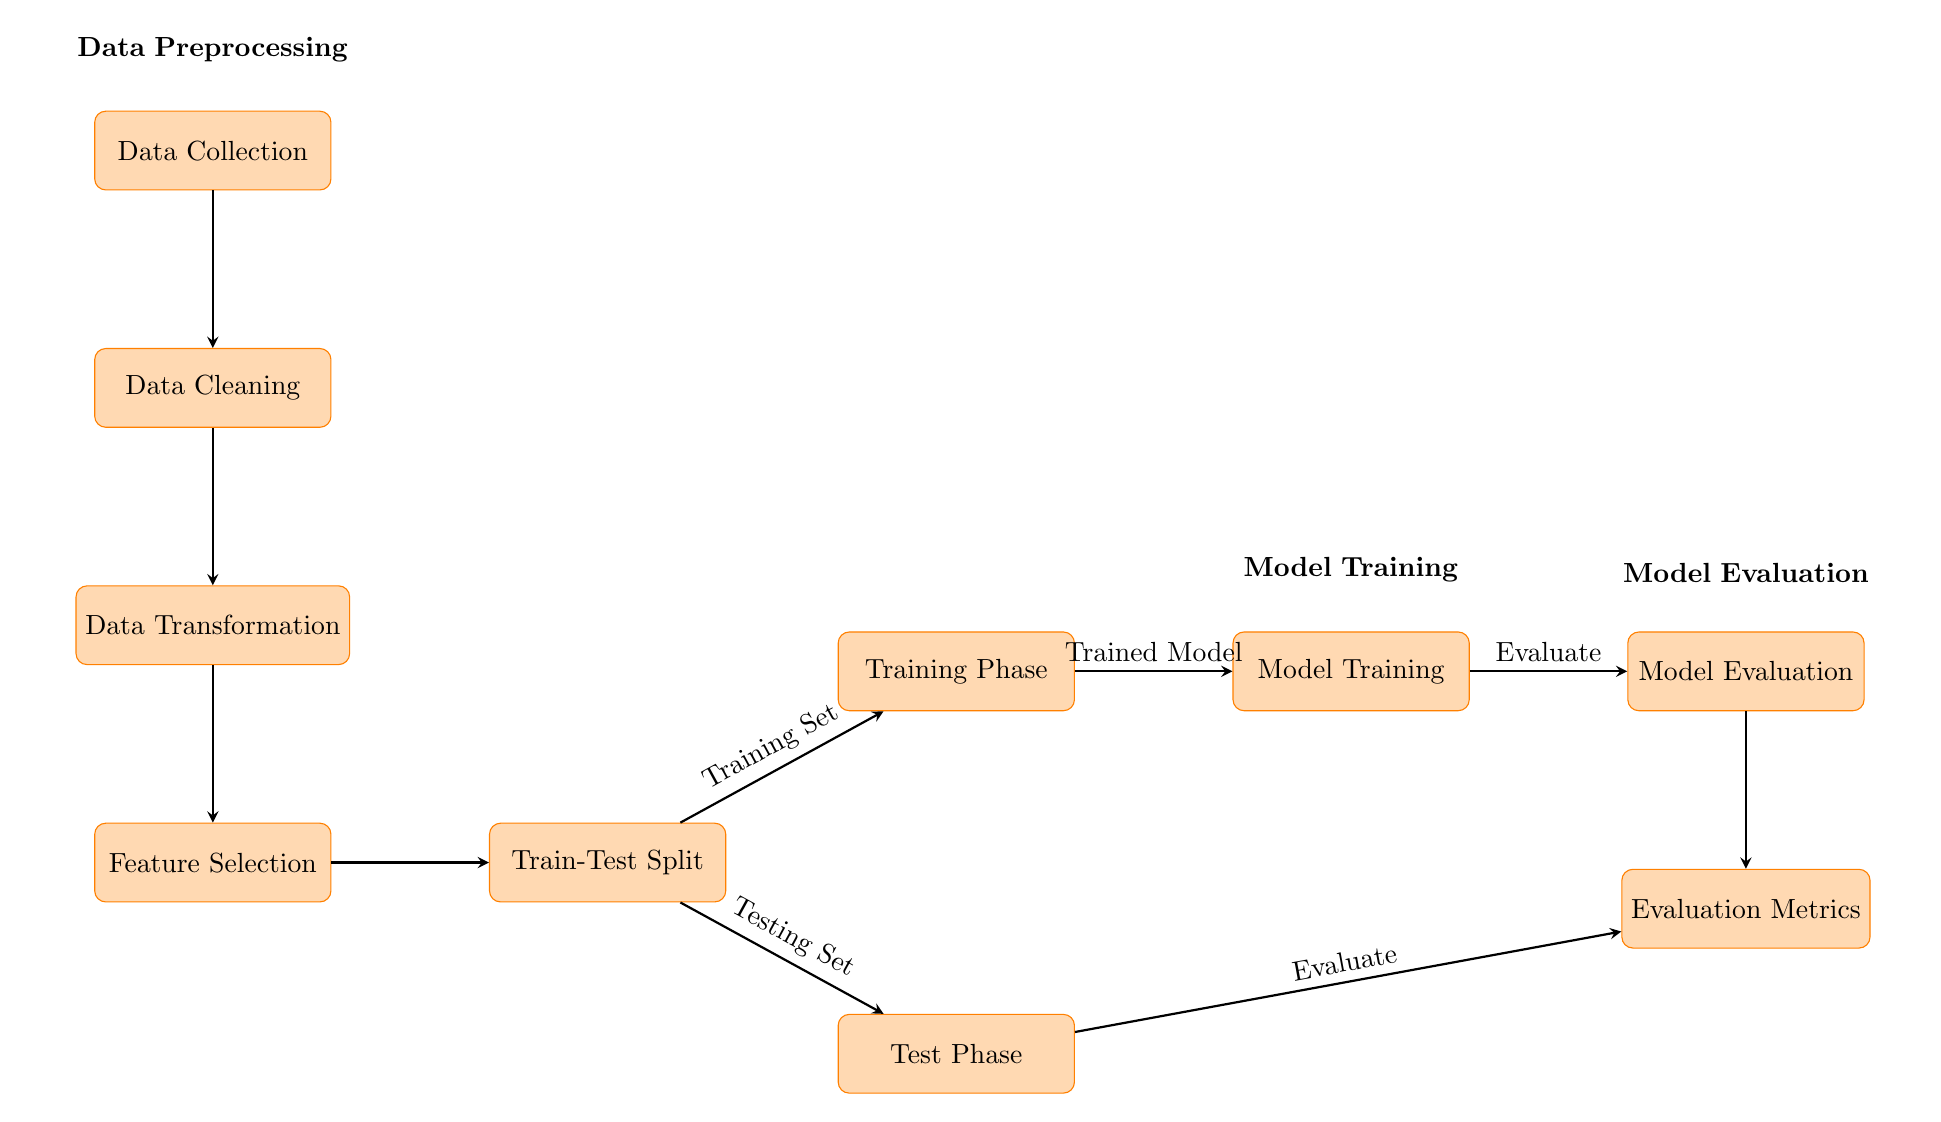What is the first step in the process? The first step in the diagram is "Data Collection," which is located at the top. This step initiates the flow that moves downward through the stages of preprocessing.
Answer: Data Collection How many processes are there in the Data Preprocessing phase? The diagram shows four processes in the Data Preprocessing phase: Data Collection, Data Cleaning, Data Transformation, and Feature Selection, listed vertically.
Answer: Four Which node receives input from the Feature Selection node? The "Train-Test Split" node receives input directly from the "Feature Selection" node, as indicated by the arrow connecting them to the right.
Answer: Train-Test Split What is the output of the Model Training phase? The output of the Model Training phase is labeled as "Trained Model," which flows to the "Model Evaluation" node.
Answer: Trained Model How are the Testing Set and Training Set related in this diagram? Both the Testing Set and Training Set are outputs from the "Train-Test Split" node; they serve as separate datasets for training and evaluating the model.
Answer: They branch from the Train-Test Split What happens after the Model Evaluation process? The process continues to the "Evaluation Metrics" node, which is where the results from the model evaluation are quantified and displayed.
Answer: Evaluation Metrics Which phase includes the node for "Data Cleaning"? "Data Cleaning" is included in the Data Preprocessing phase, which is the first phase of the whole diagram, as seen positioned below Data Collection.
Answer: Data Preprocessing What connects the Training Phase to Model Training? An arrow connects the "Training Phase" to the "Model Training" node, indicating that the training phase leads directly to the model being trained.
Answer: An arrow How many total arrows are in this diagram? There are eight arrows in total, showing the flow from one process to another across the different phases of the model training and evaluation process.
Answer: Eight 